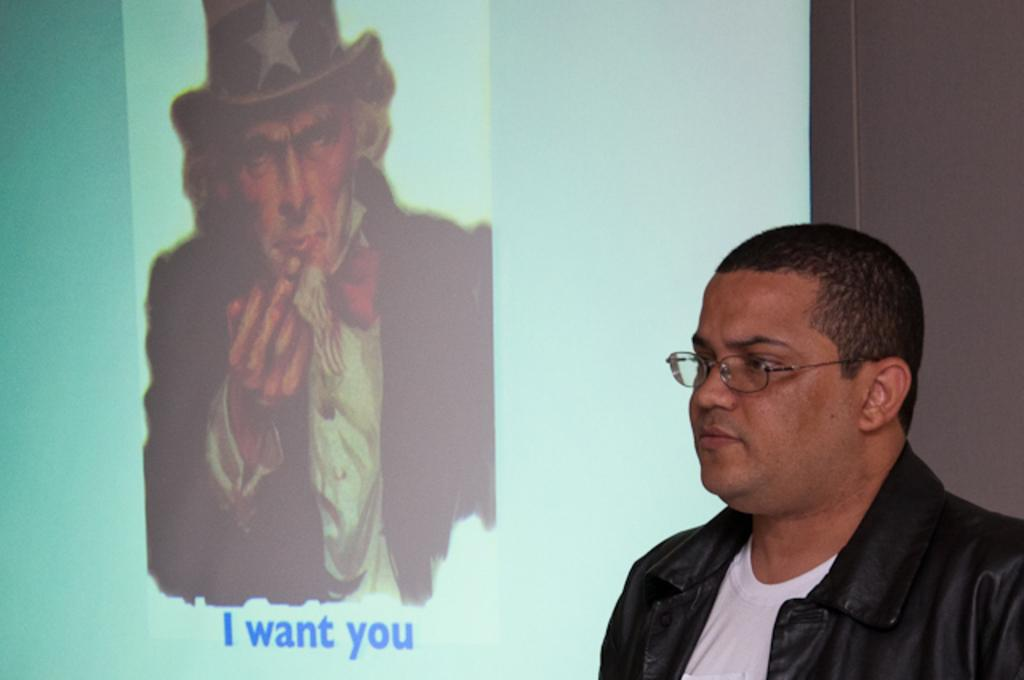Where is the person located in the image? There is a person standing in the bottom right corner of the image. What is behind the person in the image? There is a wall behind the person. What is on the wall in the image? There is a screen on the wall. What can be seen on the screen? A person is visible on the screen, and alphabets are present. What type of protest is happening in the image? There is no protest visible in the image; it only shows a person standing in front of a screen with alphabets on it. Can you tell me how many grandmothers are present in the image? There is no grandmother present in the image. 